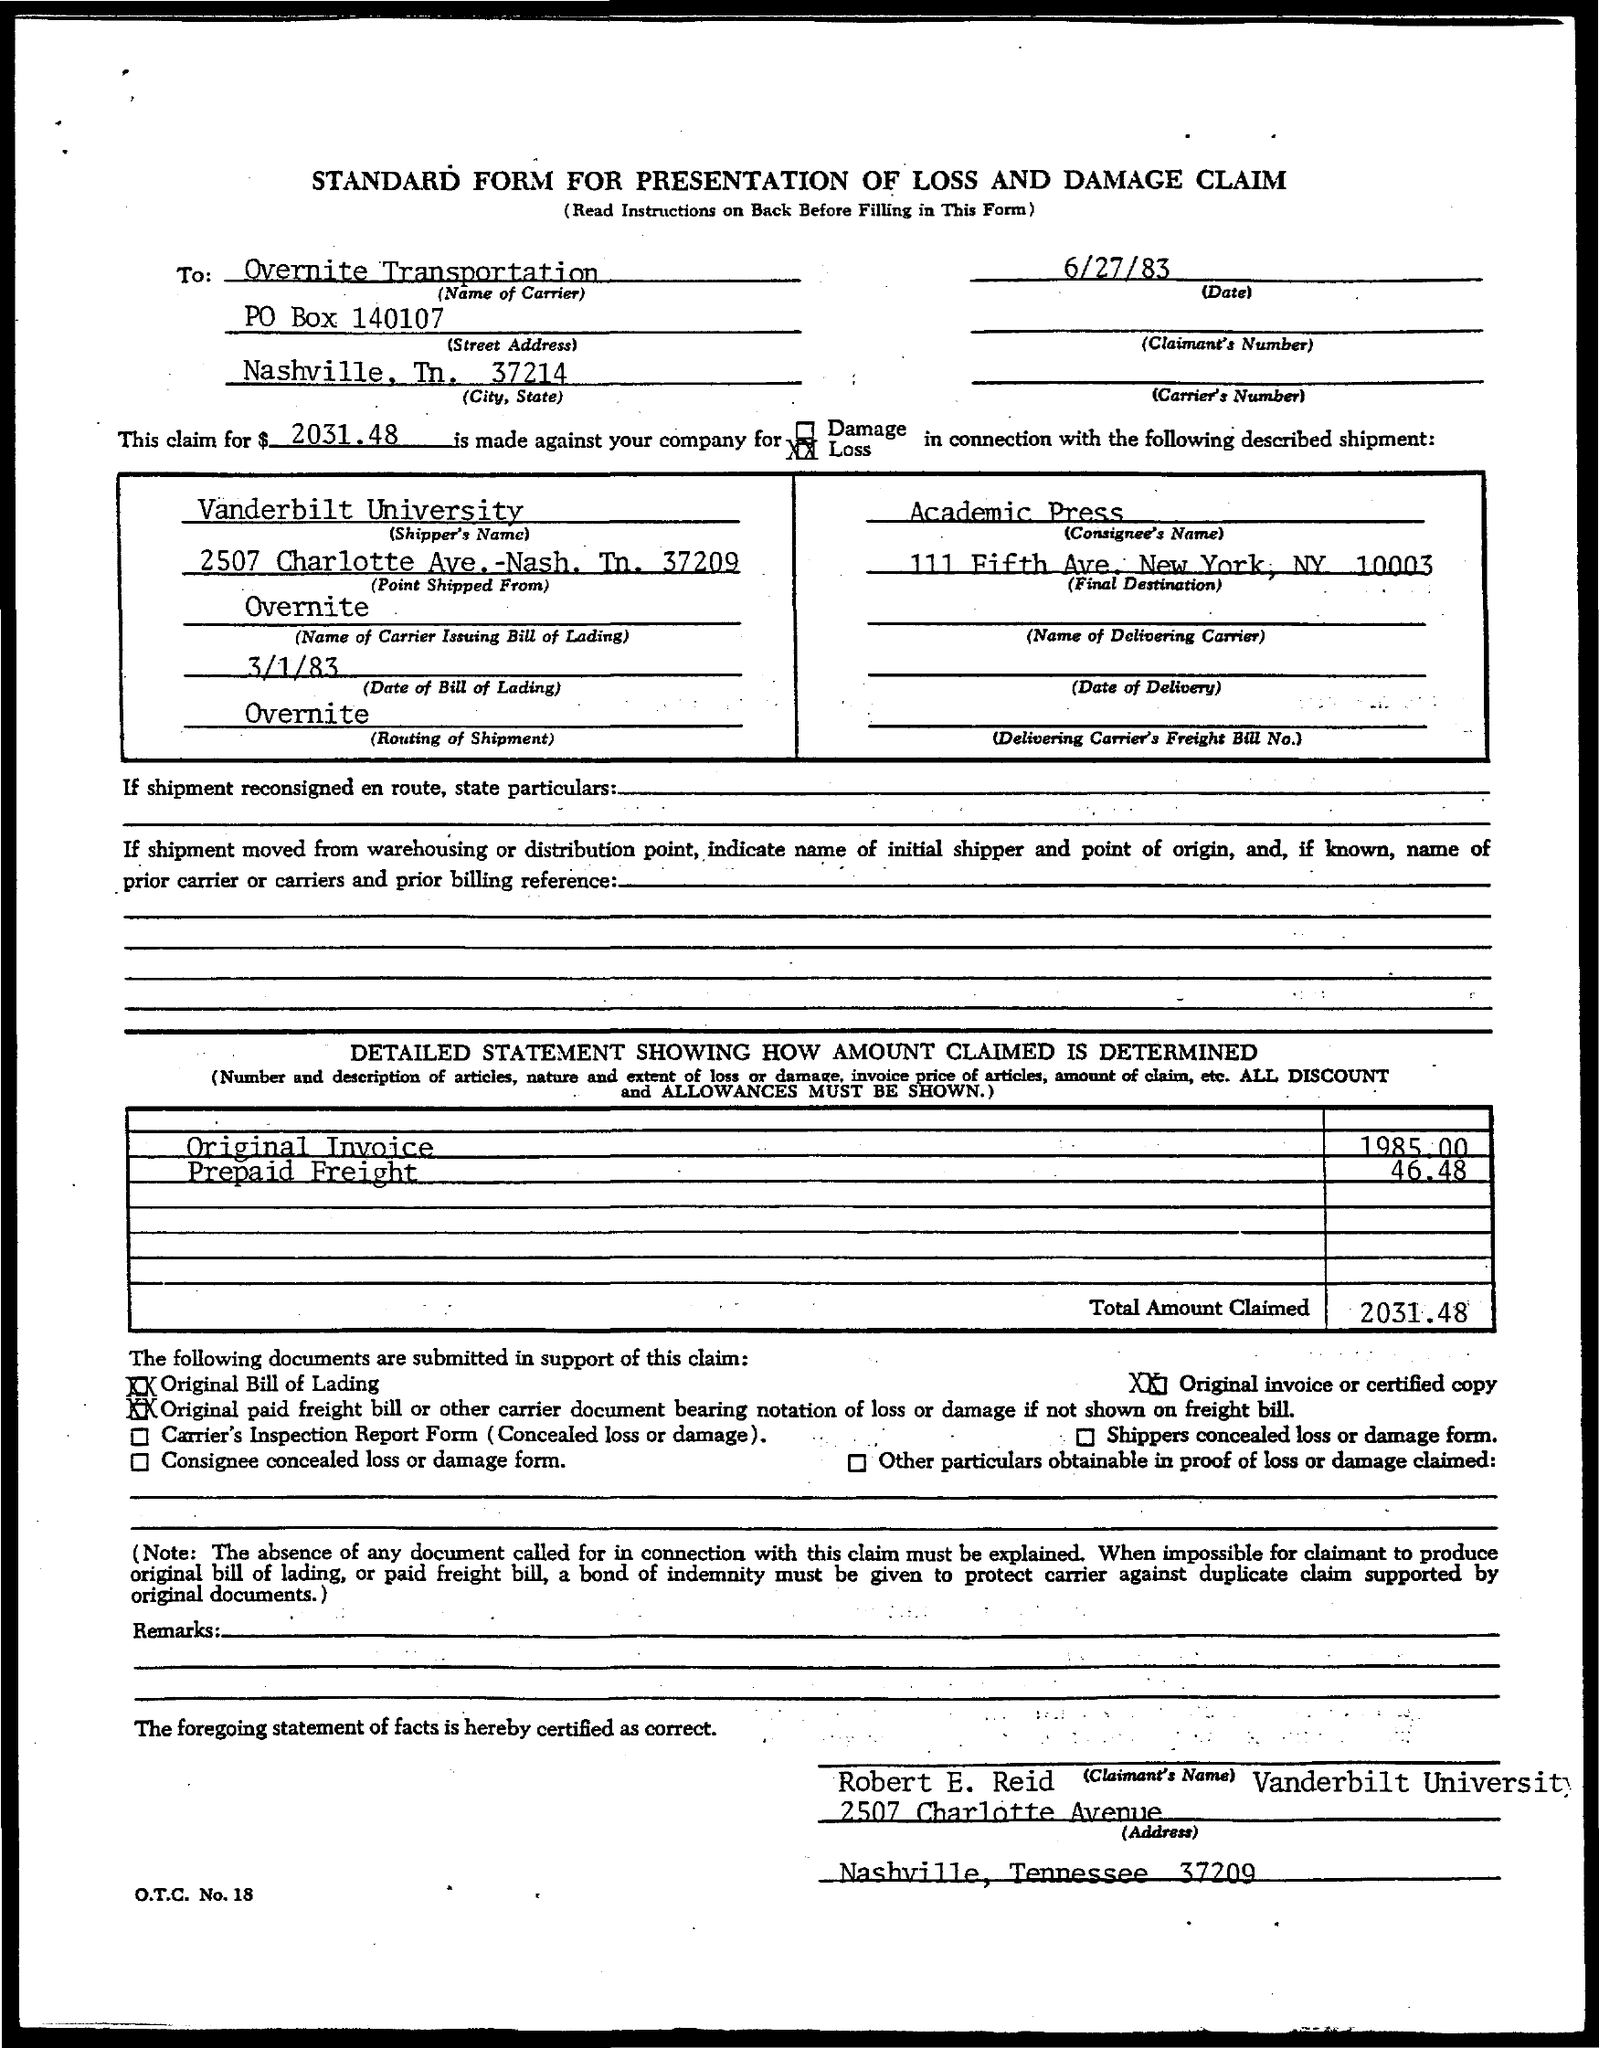Outline some significant characteristics in this image. The date of the bill of loading is March 1, 1983. The total amount claimed is 2031.48 dollars. The consigner's name is Academic Press. The carrier's name is Overnite Transportation. What is the original invoice amount? This date is 1985 and there is a decimal point in the amount. 